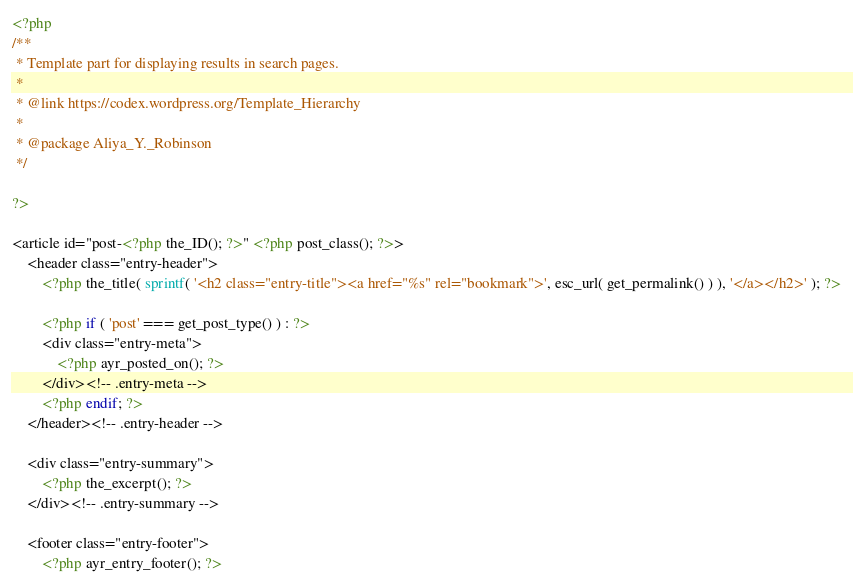<code> <loc_0><loc_0><loc_500><loc_500><_PHP_><?php
/**
 * Template part for displaying results in search pages.
 *
 * @link https://codex.wordpress.org/Template_Hierarchy
 *
 * @package Aliya_Y._Robinson
 */

?>

<article id="post-<?php the_ID(); ?>" <?php post_class(); ?>>
	<header class="entry-header">
		<?php the_title( sprintf( '<h2 class="entry-title"><a href="%s" rel="bookmark">', esc_url( get_permalink() ) ), '</a></h2>' ); ?>

		<?php if ( 'post' === get_post_type() ) : ?>
		<div class="entry-meta">
			<?php ayr_posted_on(); ?>
		</div><!-- .entry-meta -->
		<?php endif; ?>
	</header><!-- .entry-header -->

	<div class="entry-summary">
		<?php the_excerpt(); ?>
	</div><!-- .entry-summary -->

	<footer class="entry-footer">
		<?php ayr_entry_footer(); ?></code> 